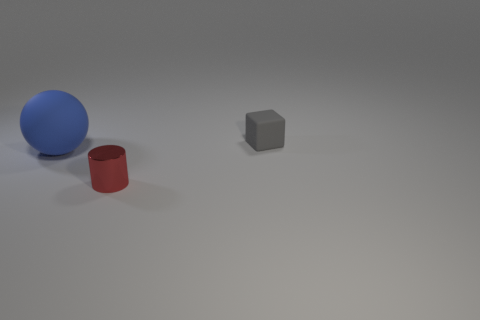The large ball has what color?
Your response must be concise. Blue. Is there a small cube?
Give a very brief answer. Yes. Are there any small blocks behind the blue matte sphere?
Provide a succinct answer. Yes. Is there any other thing that is the same material as the red object?
Your answer should be compact. No. What number of other things are there of the same shape as the big matte object?
Your answer should be very brief. 0. There is a tiny object right of the small object that is in front of the tiny gray thing; what number of tiny cubes are behind it?
Provide a short and direct response. 0. There is a small thing that is right of the tiny object on the left side of the small thing behind the ball; what is its shape?
Offer a terse response. Cube. Does the gray cube have the same size as the thing that is in front of the large blue rubber thing?
Provide a succinct answer. Yes. Are there any rubber blocks of the same size as the metallic thing?
Your response must be concise. Yes. What number of other things are the same material as the gray object?
Offer a terse response. 1. 